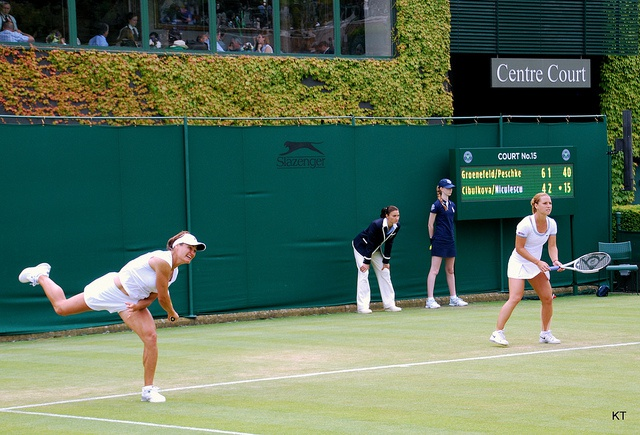Describe the objects in this image and their specific colors. I can see people in black, lavender, salmon, lightpink, and teal tones, people in black, lavender, lightpink, salmon, and brown tones, people in black, teal, white, and gray tones, people in black, lavender, darkgray, and teal tones, and people in black, navy, darkgray, and lavender tones in this image. 